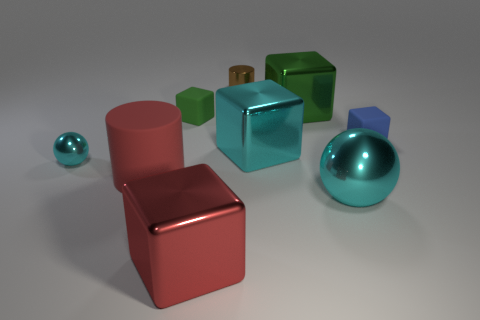Subtract all cyan cubes. How many cubes are left? 4 Subtract all small green rubber cubes. How many cubes are left? 4 Subtract all yellow blocks. Subtract all cyan spheres. How many blocks are left? 5 Subtract all cylinders. How many objects are left? 7 Subtract all brown objects. Subtract all large metal blocks. How many objects are left? 5 Add 6 green things. How many green things are left? 8 Add 8 big blue cylinders. How many big blue cylinders exist? 8 Subtract 0 purple cubes. How many objects are left? 9 